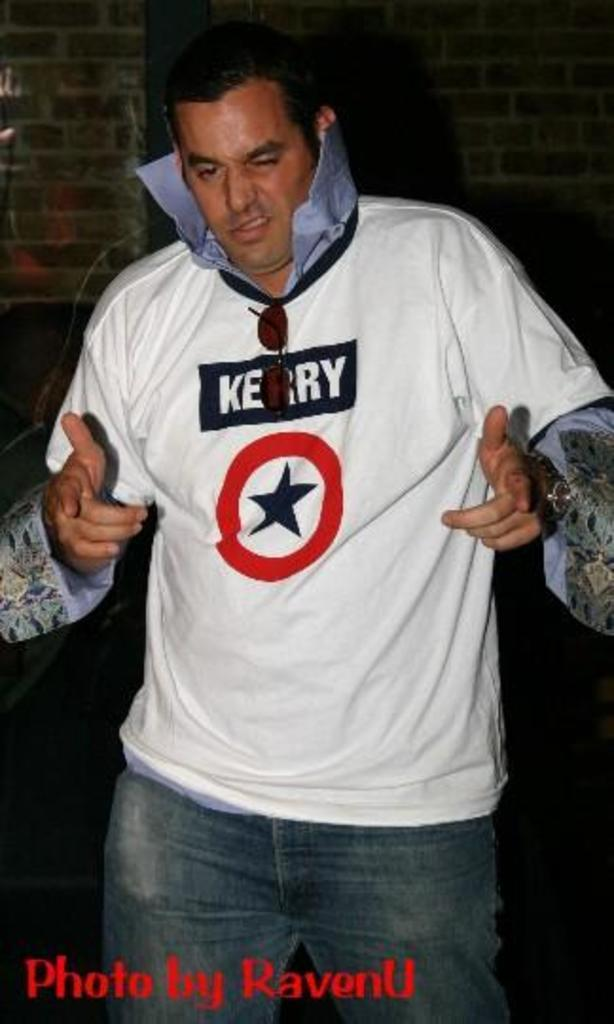<image>
Share a concise interpretation of the image provided. A man with a popped collar and Kerry on his shirt. 